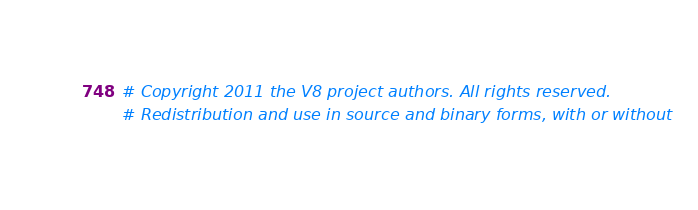<code> <loc_0><loc_0><loc_500><loc_500><_Python_># Copyright 2011 the V8 project authors. All rights reserved.
# Redistribution and use in source and binary forms, with or without</code> 